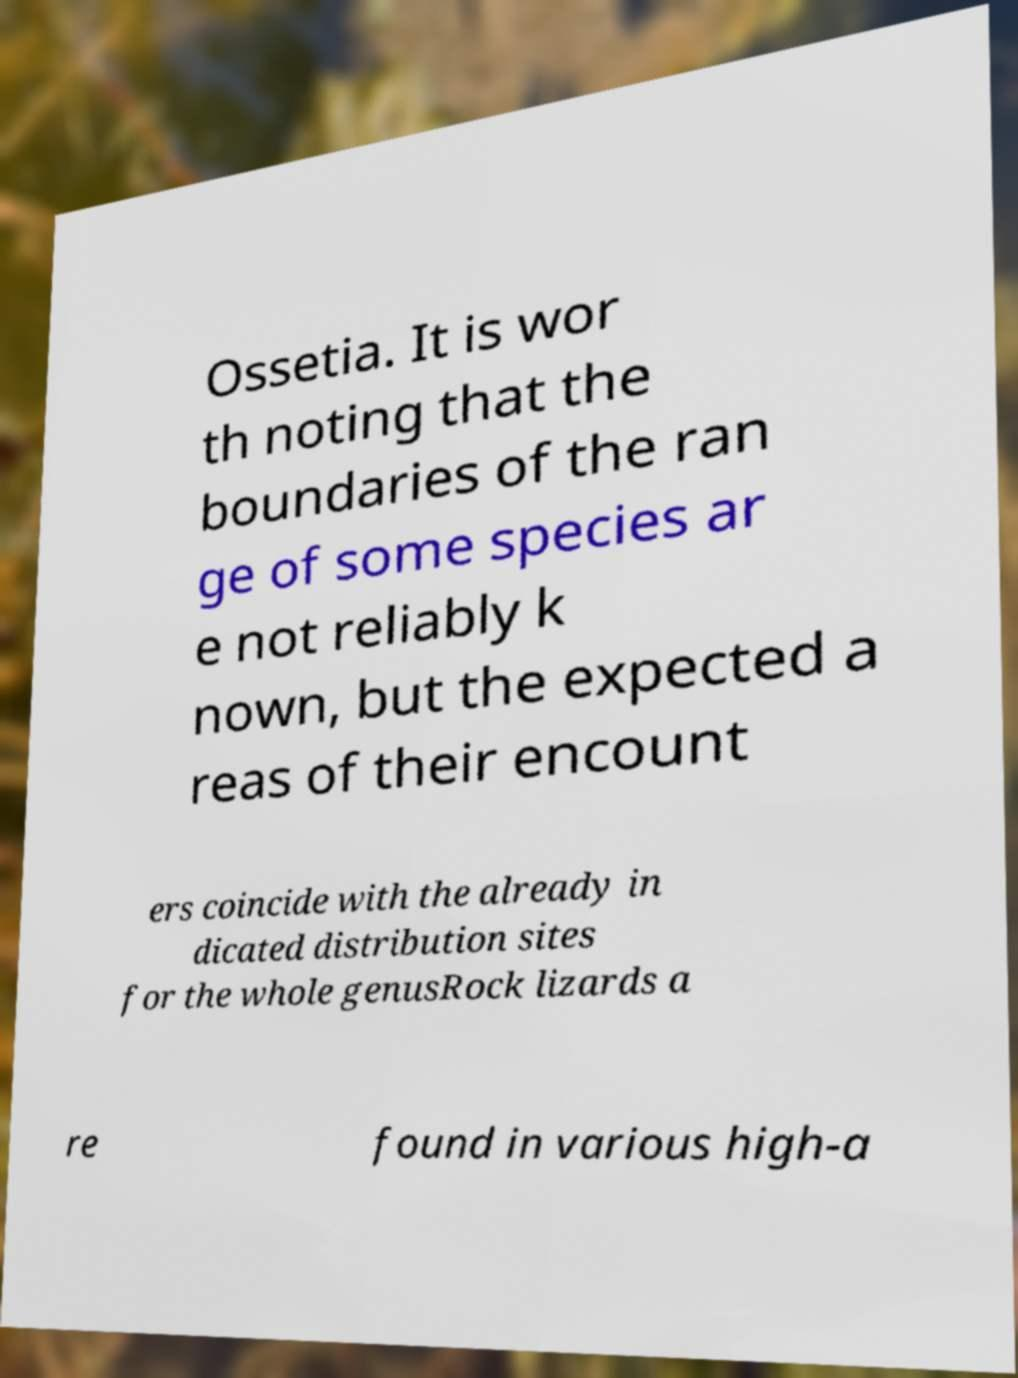I need the written content from this picture converted into text. Can you do that? Ossetia. It is wor th noting that the boundaries of the ran ge of some species ar e not reliably k nown, but the expected a reas of their encount ers coincide with the already in dicated distribution sites for the whole genusRock lizards a re found in various high-a 